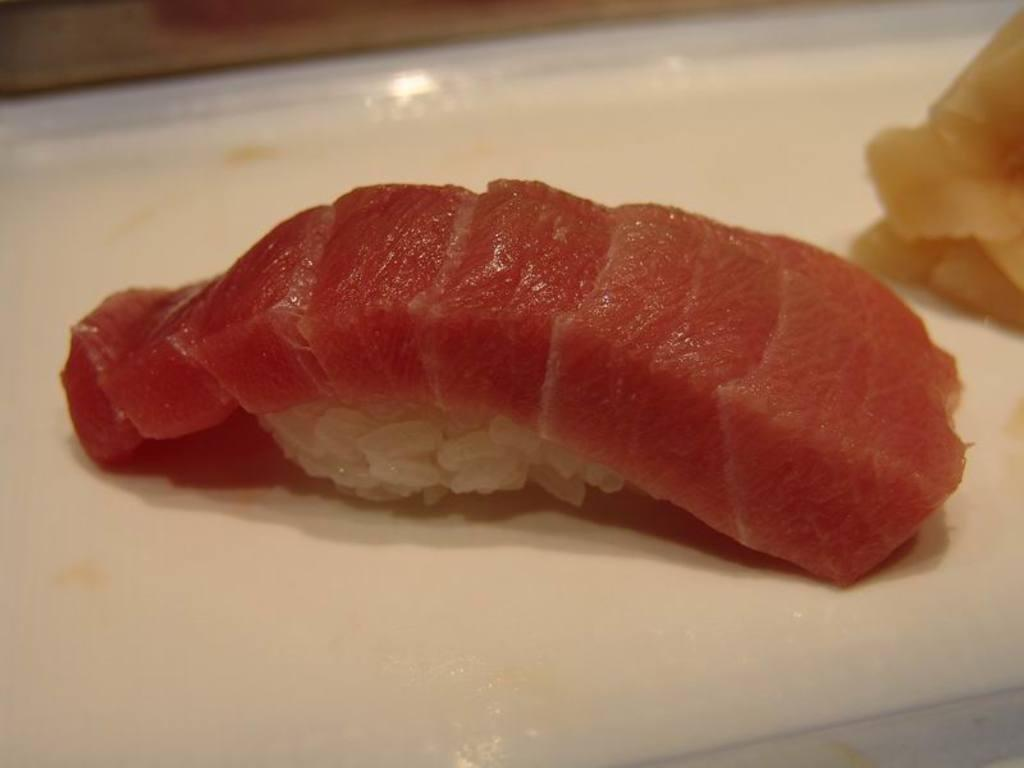What is on the plate in the image? There is a plate containing food in the image. Can you tell me how many kitties are touching the food on the plate in the image? There are no kitties present in the image, and therefore no such interaction can be observed. 